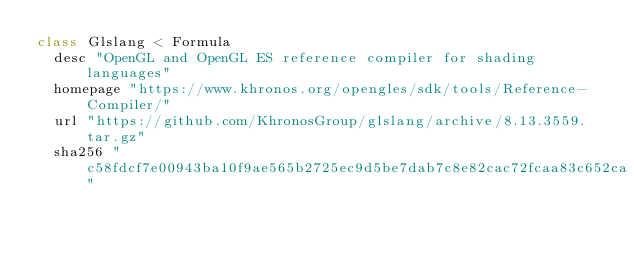Convert code to text. <code><loc_0><loc_0><loc_500><loc_500><_Ruby_>class Glslang < Formula
  desc "OpenGL and OpenGL ES reference compiler for shading languages"
  homepage "https://www.khronos.org/opengles/sdk/tools/Reference-Compiler/"
  url "https://github.com/KhronosGroup/glslang/archive/8.13.3559.tar.gz"
  sha256 "c58fdcf7e00943ba10f9ae565b2725ec9d5be7dab7c8e82cac72fcaa83c652ca"</code> 